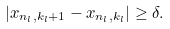<formula> <loc_0><loc_0><loc_500><loc_500>\left | x _ { n _ { l } , k _ { l } + 1 } - x _ { n _ { l } , k _ { l } } \right | \geq \delta .</formula> 